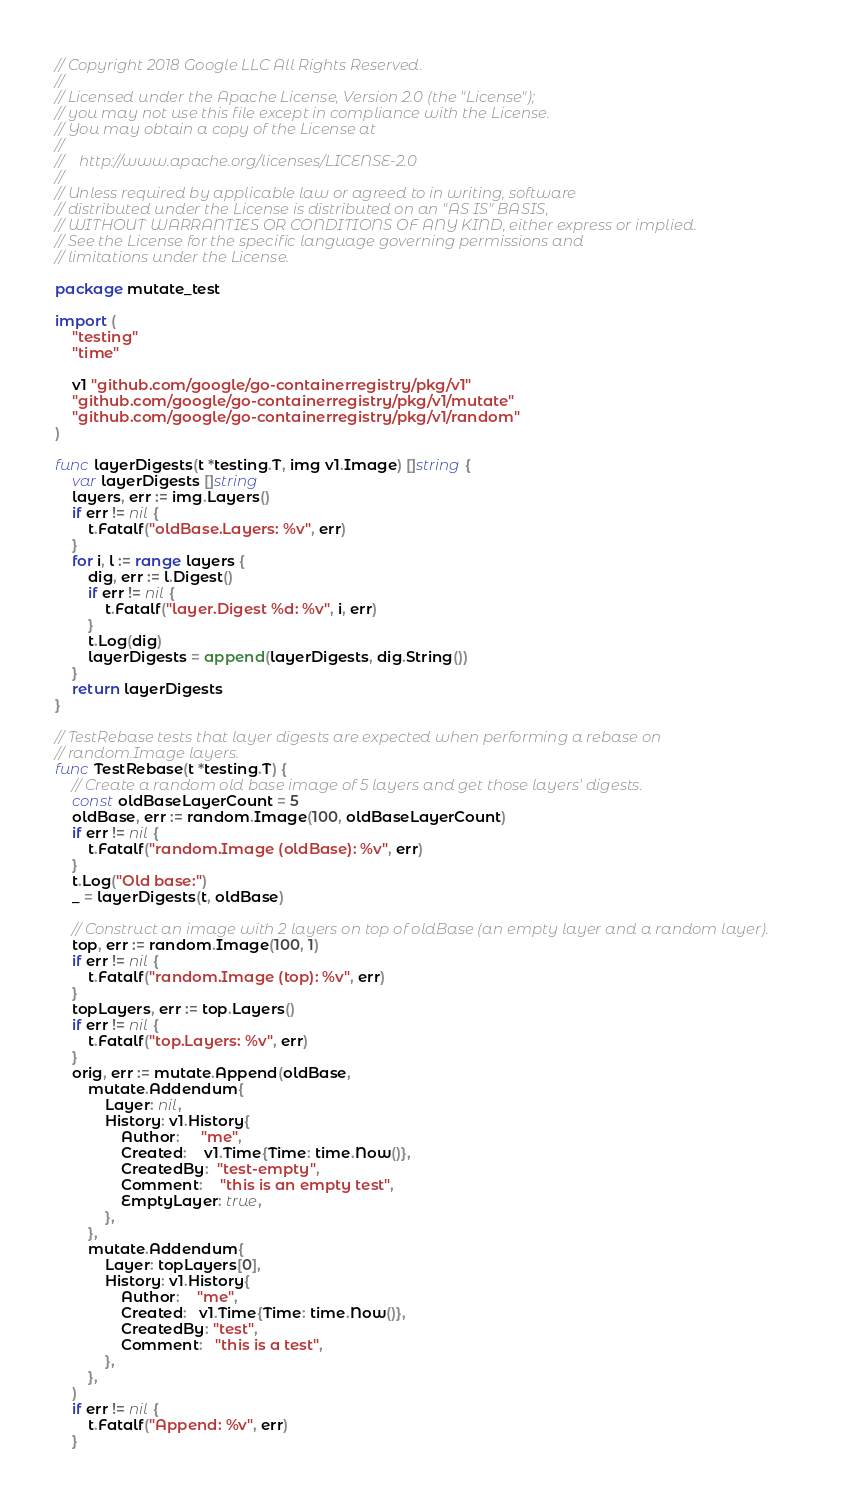<code> <loc_0><loc_0><loc_500><loc_500><_Go_>// Copyright 2018 Google LLC All Rights Reserved.
//
// Licensed under the Apache License, Version 2.0 (the "License");
// you may not use this file except in compliance with the License.
// You may obtain a copy of the License at
//
//    http://www.apache.org/licenses/LICENSE-2.0
//
// Unless required by applicable law or agreed to in writing, software
// distributed under the License is distributed on an "AS IS" BASIS,
// WITHOUT WARRANTIES OR CONDITIONS OF ANY KIND, either express or implied.
// See the License for the specific language governing permissions and
// limitations under the License.

package mutate_test

import (
	"testing"
	"time"

	v1 "github.com/google/go-containerregistry/pkg/v1"
	"github.com/google/go-containerregistry/pkg/v1/mutate"
	"github.com/google/go-containerregistry/pkg/v1/random"
)

func layerDigests(t *testing.T, img v1.Image) []string {
	var layerDigests []string
	layers, err := img.Layers()
	if err != nil {
		t.Fatalf("oldBase.Layers: %v", err)
	}
	for i, l := range layers {
		dig, err := l.Digest()
		if err != nil {
			t.Fatalf("layer.Digest %d: %v", i, err)
		}
		t.Log(dig)
		layerDigests = append(layerDigests, dig.String())
	}
	return layerDigests
}

// TestRebase tests that layer digests are expected when performing a rebase on
// random.Image layers.
func TestRebase(t *testing.T) {
	// Create a random old base image of 5 layers and get those layers' digests.
	const oldBaseLayerCount = 5
	oldBase, err := random.Image(100, oldBaseLayerCount)
	if err != nil {
		t.Fatalf("random.Image (oldBase): %v", err)
	}
	t.Log("Old base:")
	_ = layerDigests(t, oldBase)

	// Construct an image with 2 layers on top of oldBase (an empty layer and a random layer).
	top, err := random.Image(100, 1)
	if err != nil {
		t.Fatalf("random.Image (top): %v", err)
	}
	topLayers, err := top.Layers()
	if err != nil {
		t.Fatalf("top.Layers: %v", err)
	}
	orig, err := mutate.Append(oldBase,
		mutate.Addendum{
			Layer: nil,
			History: v1.History{
				Author:     "me",
				Created:    v1.Time{Time: time.Now()},
				CreatedBy:  "test-empty",
				Comment:    "this is an empty test",
				EmptyLayer: true,
			},
		},
		mutate.Addendum{
			Layer: topLayers[0],
			History: v1.History{
				Author:    "me",
				Created:   v1.Time{Time: time.Now()},
				CreatedBy: "test",
				Comment:   "this is a test",
			},
		},
	)
	if err != nil {
		t.Fatalf("Append: %v", err)
	}
</code> 